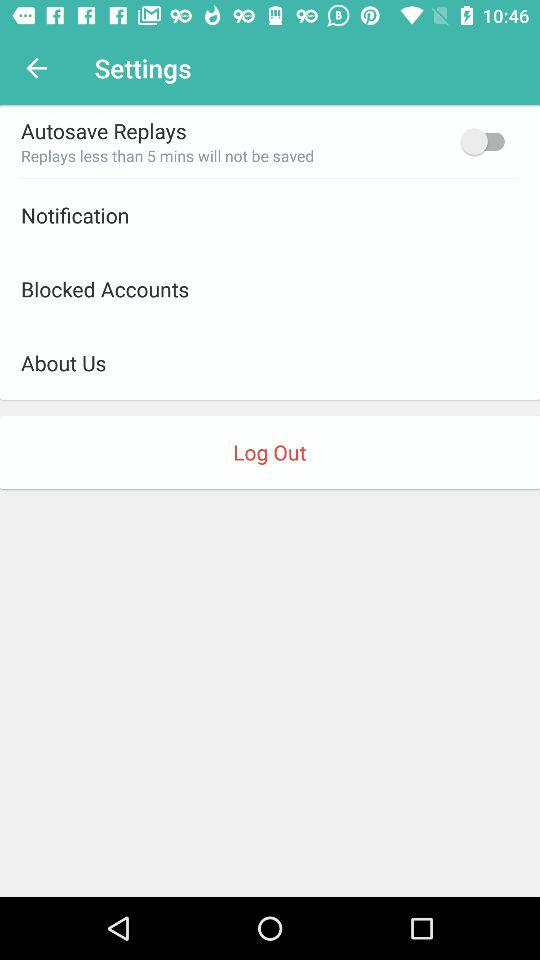How many items are in the Settings menu?
Answer the question using a single word or phrase. 5 